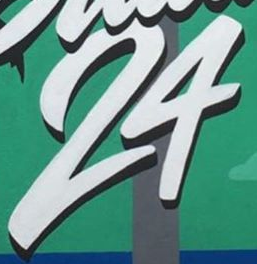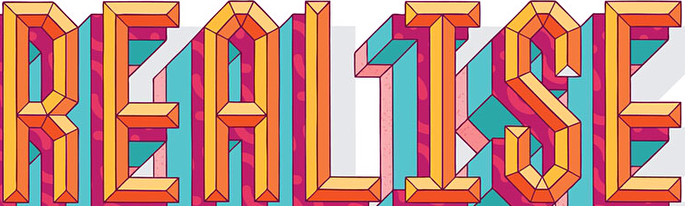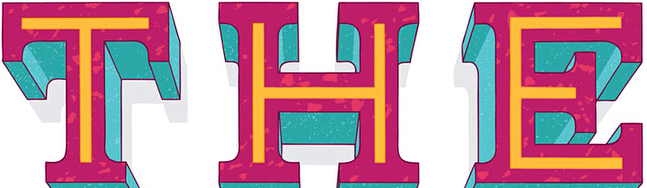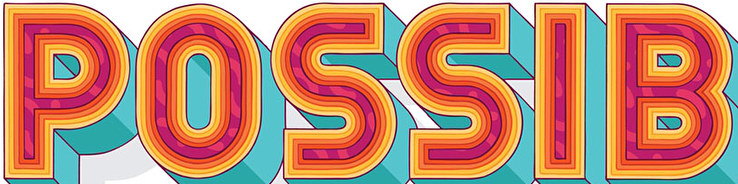Read the text content from these images in order, separated by a semicolon. 24; REALISE; THE; POSSIB 